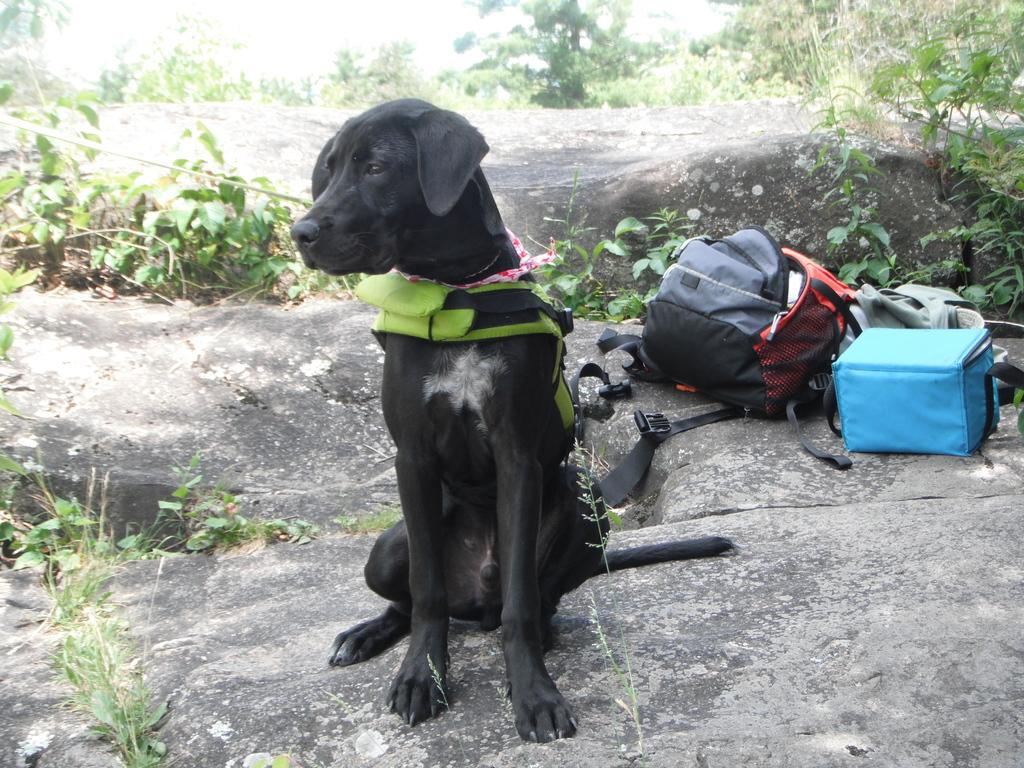What is the main subject of the image? There is a dog in the middle of the image. What is the dog doing in the image? The dog is staring at something. What can be seen on the right side of the image? There are bags on the right side of the image. What is visible in the background of the image? There are trees and plants in the background of the image. What is the size of the dog's muscles in the image? The size of the dog's muscles cannot be determined from the image alone, as it does not provide enough detail about the dog's physical features. 